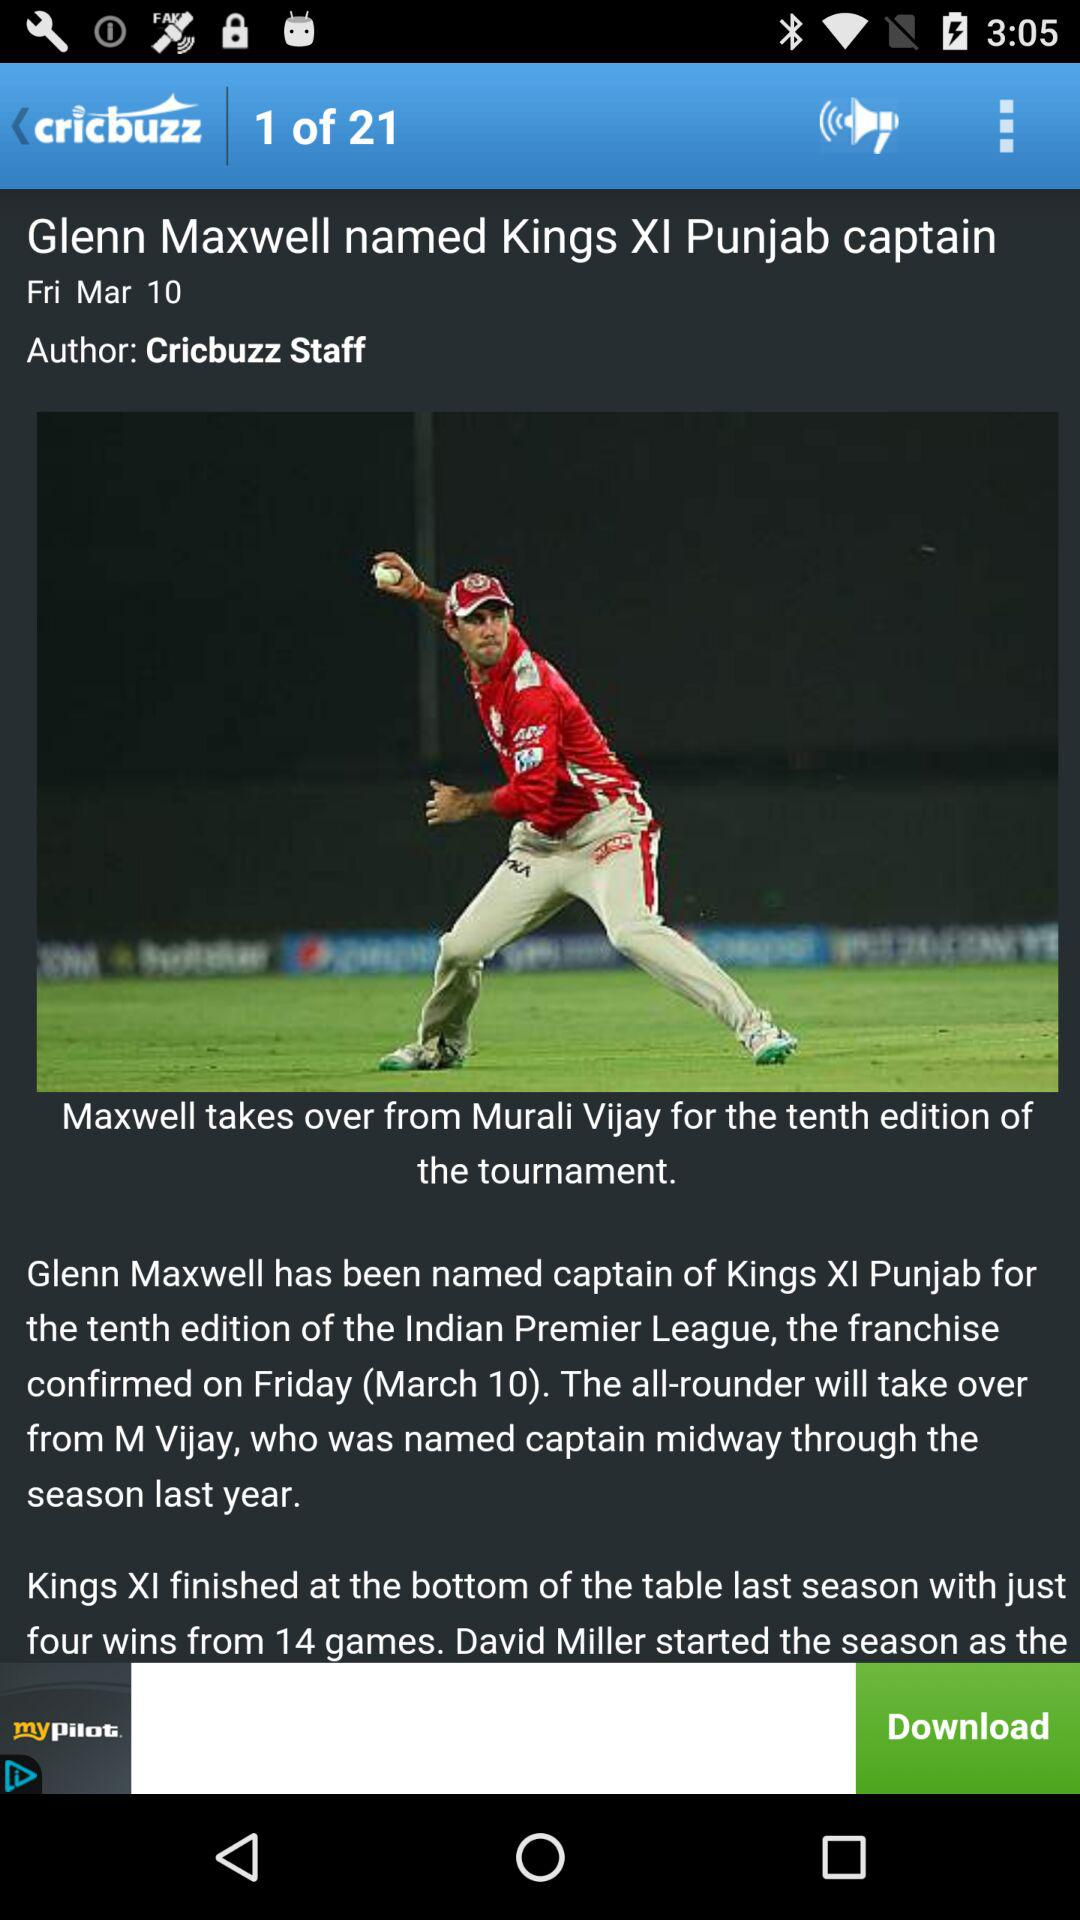What is the name of the application? The name of the application is "cricbuzz". 